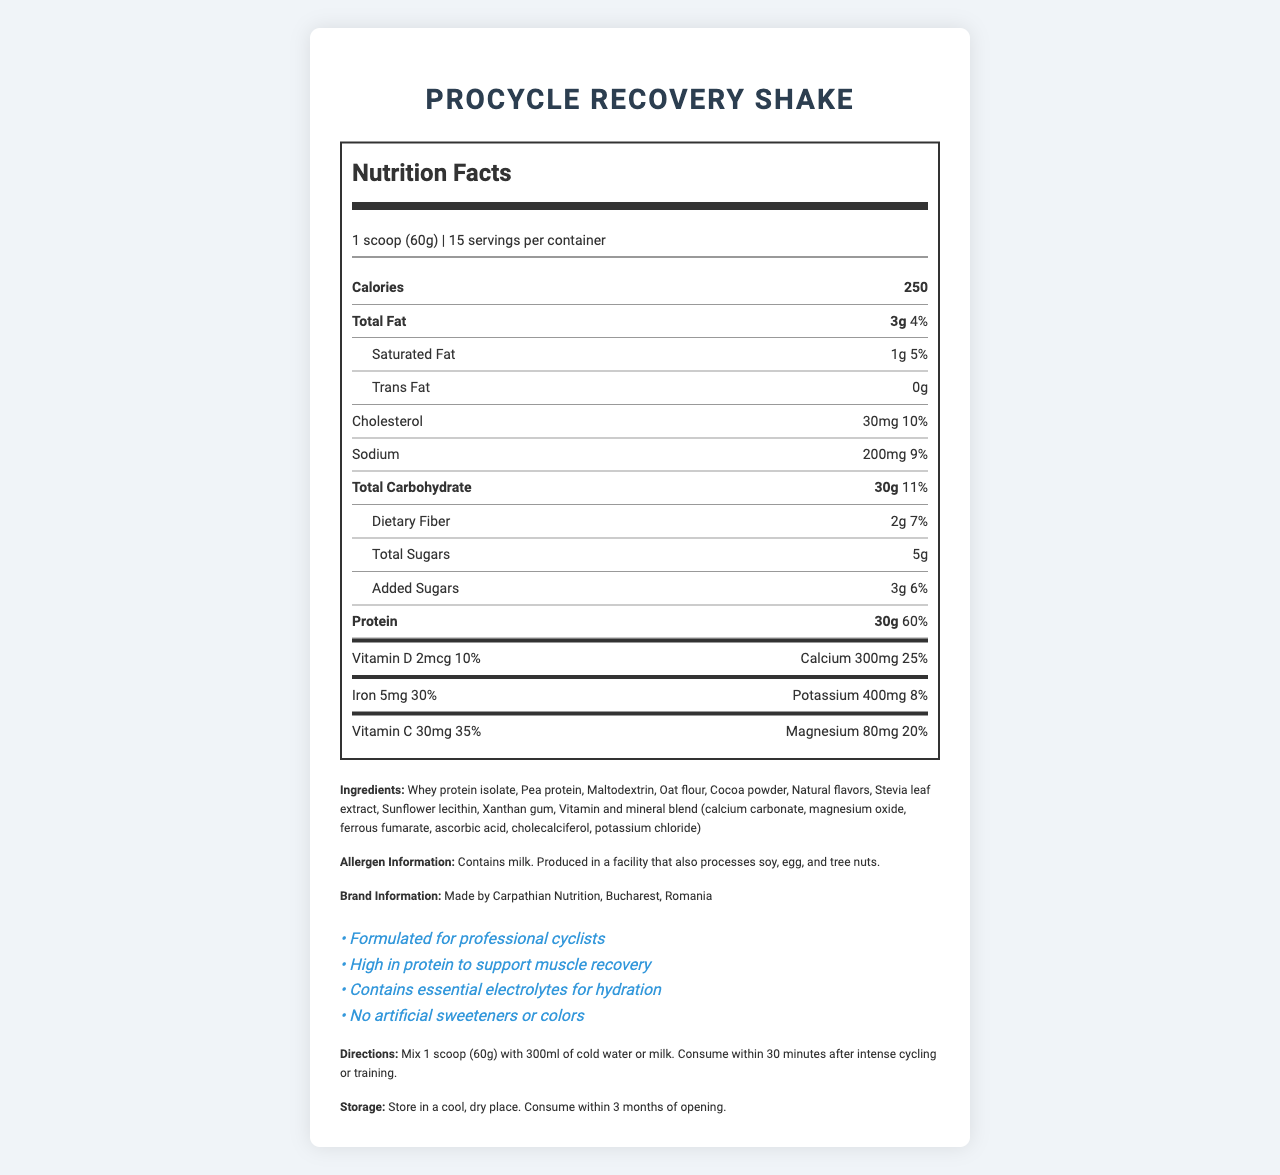what is the serving size? The serving size is listed under the nutrition facts and states "1 scoop (60g)".
Answer: 1 scoop (60g) how many calories are in one serving? The calories per serving are indicated as 250.
Answer: 250 what is the total fat content per serving? The document states that the total fat per serving is 3g.
Answer: 3g how many grams of dietary fiber are in each serving? The dietary fiber per serving is listed as 2g.
Answer: 2g what is the daily value percentage of calcium in one serving? The daily value percentage for calcium is provided as 25%.
Answer: 25% which ingredient makes up the protein content of the shake? A. Whey protein isolate B. Cocoa powder C. Maltodextrin D. Stevia leaf extract The primary protein ingredients listed are "Whey protein isolate" and "Pea protein", but the question asks for the ingredient, of which "Whey protein isolate" is the most common in such shakes.
Answer: A. Whey protein isolate What is the main purpose of this product according to the claims section? The product is described as "High in protein to support muscle recovery" and "Formulated for professional cyclists" in the claims section.
Answer: To support muscle recovery for professional cyclists True or False: This product contains artificial sweeteners. The claims section states "No artificial sweeteners or colors".
Answer: False list all vitamins and minerals that contribute at least 20% of the daily value per serving? These nutrients contribute at least 20% of the daily value: Calcium (25%), Iron (30%), Vitamin C (35%), Magnesium (20%), Protein (60%).
Answer: Calcium, Iron, Vitamin C, Magnesium, Protein what are the storage instructions for this product? The storage instructions section specifies these instructions.
Answer: Store in a cool, dry place. Consume within 3 months of opening. summarize the main information presented in the document. The summary brings together all the key points about the product's purpose, nutritional content, ingredients, claims, directions, and storage instructions.
Answer: The ProCycle Recovery Shake is a high-protein meal replacement formulated for professional cyclists, aimed at supporting muscle recovery. It contains essential nutrients and electrolytes, with no artificial sweeteners or colors. The serving size is 1 scoop (60g) and each serving provides 250 calories along with various vitamins and minerals. The product is produced in Bucharest, Romania, and has specific mixing and storage instructions. how much potassium is found in one serving? The amount of potassium per serving is listed as 400mg.
Answer: 400mg what type of protein is included in the ingredient list besides Whey protein isolate? The ingredients list includes "Pea protein" along with "Whey protein isolate".
Answer: Pea protein how many servings does one container have? The document specifies that there are 15 servings per container.
Answer: 15 does this product contain any tree nuts? The allergen information states the product is produced in a facility that also processes tree nuts, but it does not explicitly state whether the product itself contains tree nuts.
Answer: Cannot be determined which of the following ingredients is not listed in the ProCycle Recovery Shake? A. Sunflower lecithin B. Xanthan gum C. Soy protein D. Cocoa powder The ingredients list includes "Sunflower lecithin", "Xanthan gum", and "Cocoa powder", but does not list "Soy protein".
Answer: C. Soy protein describe how to prepare the ProCycle Recovery Shake according to the directions. The directions specify mixing 1 scoop with 300ml of cold water or milk and suggest consuming it within 30 minutes post-exercise.
Answer: Mix 1 scoop (60g) with 300ml of cold water or milk. Consume within 30 minutes after intense cycling or training. 